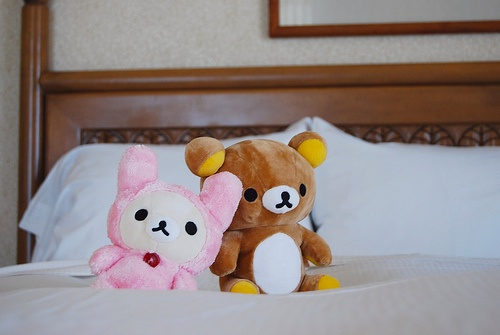Describe the objects in this image and their specific colors. I can see bed in gray, darkgray, pink, and lightgray tones, teddy bear in gray, brown, lavender, and maroon tones, and teddy bear in gray, pink, lightgray, lightpink, and darkgray tones in this image. 